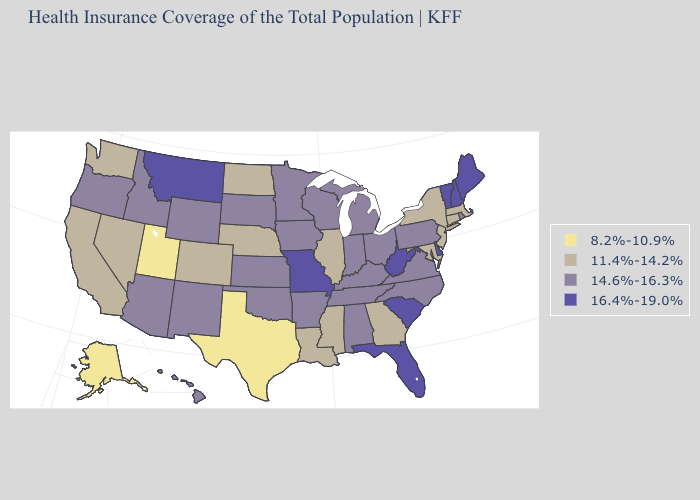Name the states that have a value in the range 11.4%-14.2%?
Answer briefly. California, Colorado, Connecticut, Georgia, Illinois, Louisiana, Maryland, Massachusetts, Mississippi, Nebraska, Nevada, New Jersey, New York, North Dakota, Washington. What is the highest value in the USA?
Write a very short answer. 16.4%-19.0%. Does Delaware have the highest value in the USA?
Write a very short answer. Yes. Name the states that have a value in the range 8.2%-10.9%?
Be succinct. Alaska, Texas, Utah. Which states hav the highest value in the West?
Write a very short answer. Montana. Which states have the lowest value in the MidWest?
Be succinct. Illinois, Nebraska, North Dakota. What is the value of New Mexico?
Keep it brief. 14.6%-16.3%. Name the states that have a value in the range 8.2%-10.9%?
Quick response, please. Alaska, Texas, Utah. What is the lowest value in the USA?
Give a very brief answer. 8.2%-10.9%. Among the states that border Indiana , does Michigan have the highest value?
Be succinct. Yes. Which states have the lowest value in the USA?
Keep it brief. Alaska, Texas, Utah. Among the states that border Ohio , which have the highest value?
Be succinct. West Virginia. Among the states that border Indiana , does Illinois have the highest value?
Keep it brief. No. Does the first symbol in the legend represent the smallest category?
Be succinct. Yes. Among the states that border Maine , which have the highest value?
Quick response, please. New Hampshire. 